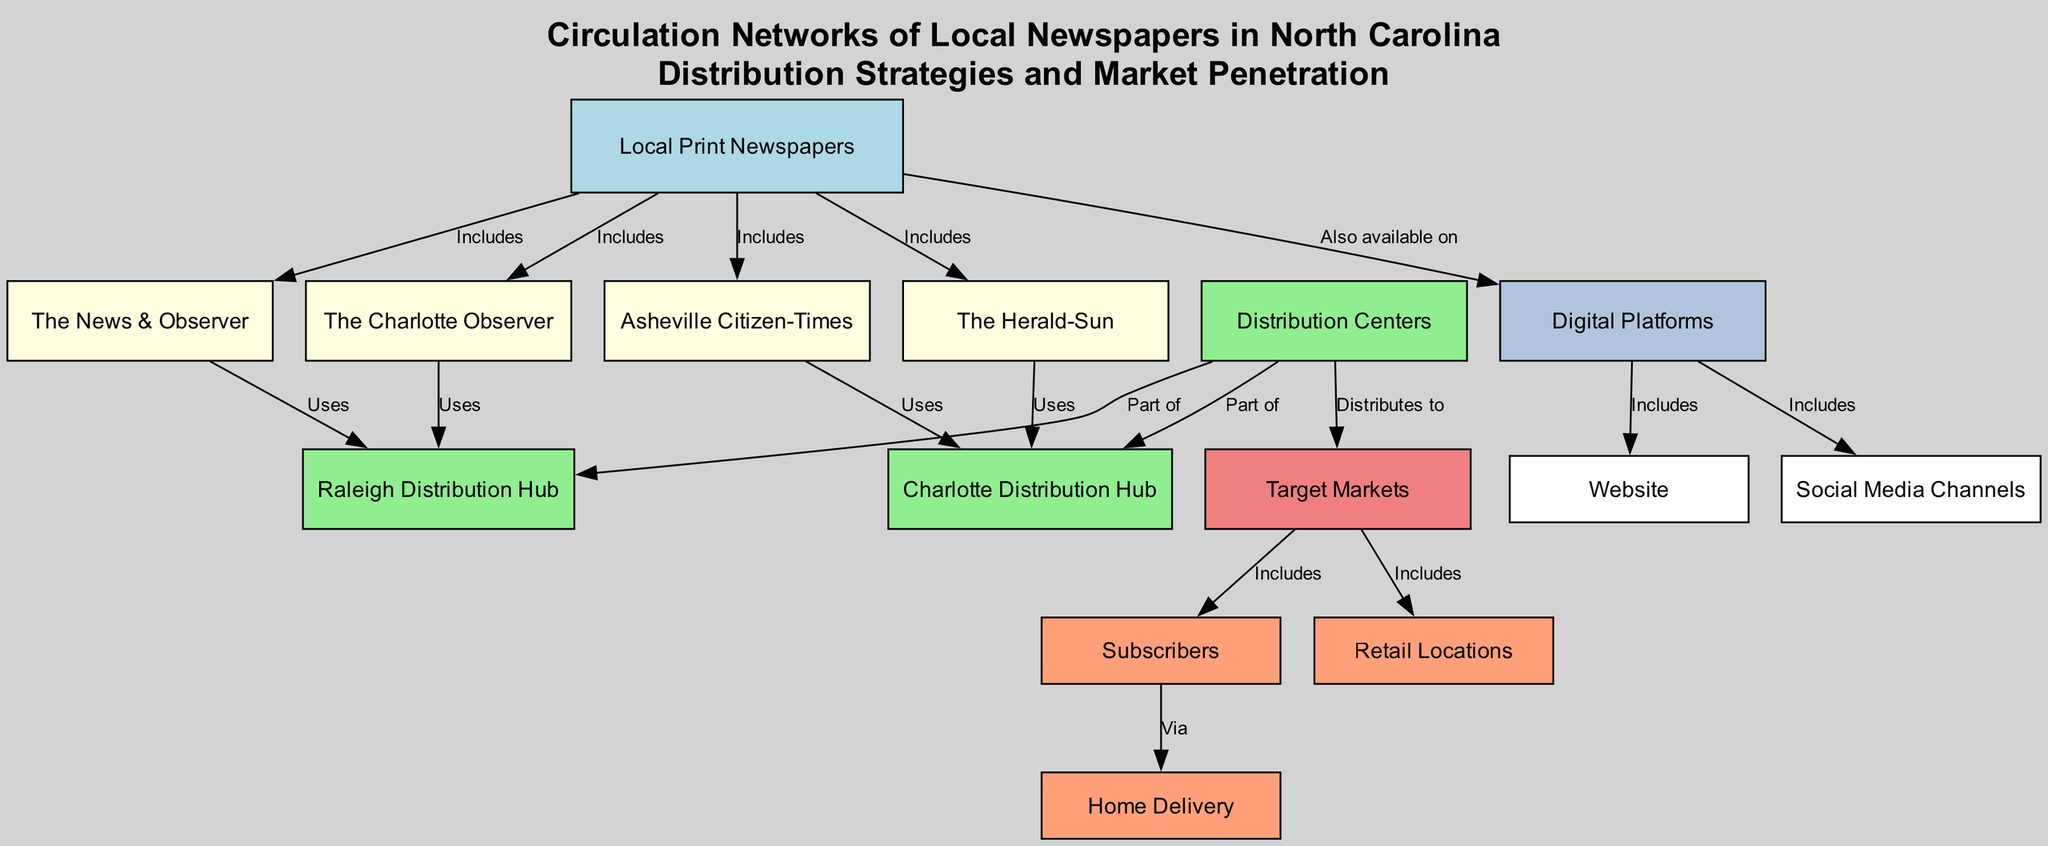What local newspapers are included in the diagram? The diagram displays four local newspapers: The Charlotte Observer, The News & Observer, Asheville Citizen-Times, and The Herald-Sun, all originating from the node labeled 'Local Print Newspapers'.
Answer: The Charlotte Observer, The News & Observer, Asheville Citizen-Times, The Herald-Sun What are the distribution hubs referenced in the diagram? The diagram features two distribution hubs: Raleigh Distribution Hub and Charlotte Distribution Hub. Each hub connects to specific local newspapers and distribution centers.
Answer: Raleigh Distribution Hub, Charlotte Distribution Hub How do the local newspapers reach their target markets? The local newspapers distribute to 'Target Markets' via 'Distribution Centers', indicating that they utilize these centers to reach their intended audience.
Answer: Distribution Centers How many local newspapers are represented in the diagram? By counting the nodes labeled for newspapers, there are four distinct local newspapers that form part of the 'Local Print Newspapers' category.
Answer: Four What method do newspapers use to deliver content to subscribers? The diagram indicates that 'Home Delivery' is one method through which local newspapers provide their content to 'Subscribers', showing a direct channel for reaching readers.
Answer: Home Delivery Which digital platforms are affiliated with the local newspapers? The highlighted digital platforms include 'Social Media Channels' and 'Website', which are indicated as extensions of the 'Digital Platforms' node where local newspapers can be accessed online.
Answer: Social Media Channels, Website Which local newspaper utilizes the Raleigh Distribution Hub? Both The Charlotte Observer and The News & Observer are noted to 'Use' the Raleigh Distribution Hub for their distribution, serving specific market areas from there.
Answer: The Charlotte Observer, The News & Observer What two categories fall under the target market for the newspapers? The 'Target Markets' node includes two categories: 'Subscribers' and 'Retail Locations', illustrating how local newspapers reach their audiences through both direct subscriptions and retail availability.
Answer: Subscribers, Retail Locations What relationships do the nodes Local Print Newspapers and Digital Platforms share? The 'Local Print Newspapers' are depicted as 'Also available on' 'Digital Platforms', showing that traditional newspapers extend their reach through online means to engage readers on various digital outlets.
Answer: Also available on 